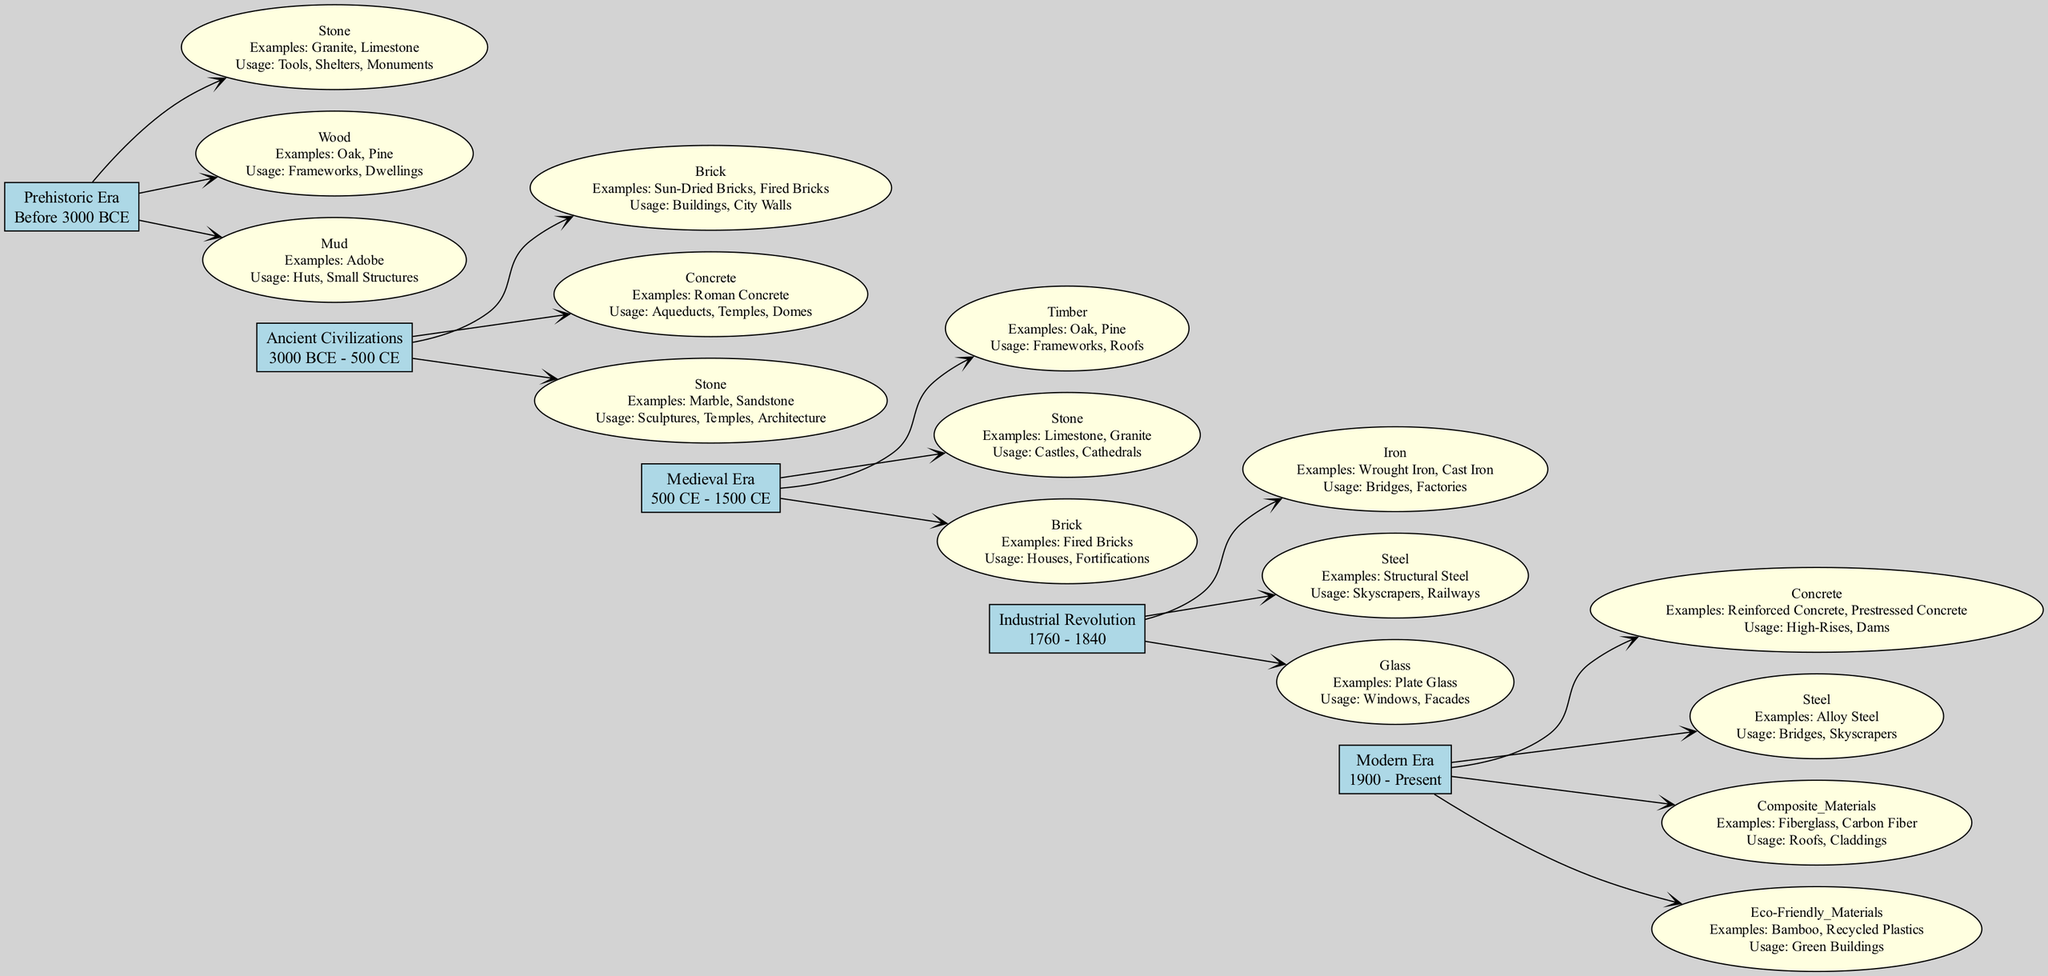What building material was used in Prehistoric Era for shelters? According to the diagram, in the Prehistoric Era, the material used for shelters was wood.
Answer: Wood Which era included the use of Roman Concrete? The diagram shows that Roman Concrete was used during the Ancient Civilizations era.
Answer: Ancient Civilizations What is the time period for the Industrial Revolution? The diagram indicates that the time period for the Industrial Revolution is from 1760 to 1840.
Answer: 1760 - 1840 How many different materials are listed for the Medieval Era? The diagram displays three different materials listed under the Medieval Era, which are Timber, Stone, and Brick.
Answer: 3 Which material was commonly used in both the Industrial Revolution and Modern Era? By examining the diagram, both Steel and Iron were common materials used during the Industrial Revolution and Modern Era. However, Steel appears in both eras, making it the overlapping material.
Answer: Steel What examples of materials were used for eco-friendly buildings in the Modern Era? According to the diagram, eco-friendly materials include Bamboo and Recycled Plastics.
Answer: Bamboo, Recycled Plastics Which material was primarily used for windows in the Industrial Revolution? The diagram specifies that during the Industrial Revolution, Glass was the primary material used for windows.
Answer: Glass In which era were fired bricks primarily used for houses? The diagram indicates that fired bricks were primarily used for houses in the Medieval Era.
Answer: Medieval Era Name one example of a material used for city walls during Ancient Civilizations. The diagram states that an example of a material used for city walls during Ancient Civilizations is Brick, specifically Sun-Dried Bricks and Fired Bricks.
Answer: Brick 